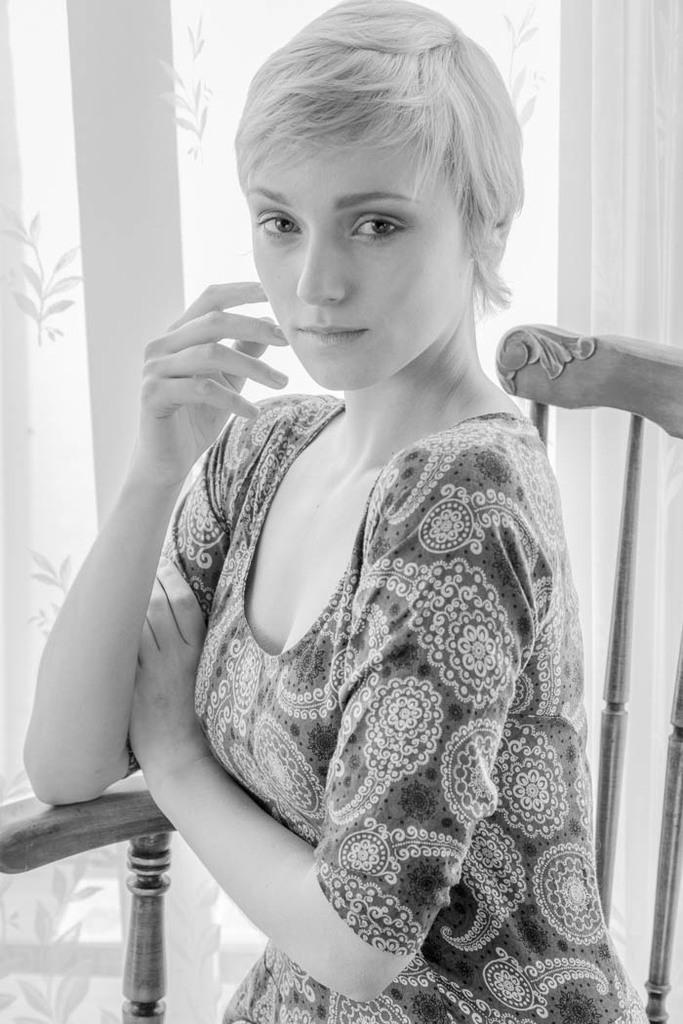What is the color scheme of the image? The image is black and white. Who is present in the image? There is a woman in the image. What is the woman doing in the image? The woman is sitting on a chair. What else can be seen in the image? There is a curtain visible in the image. What type of sock is the woman wearing in the image? There is no sock visible in the image, as the image is black and white and does not show any clothing details. 